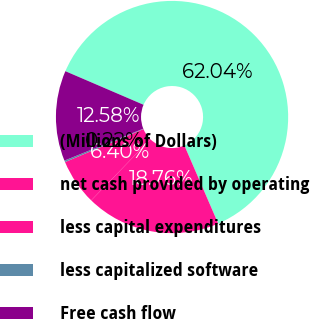Convert chart to OTSL. <chart><loc_0><loc_0><loc_500><loc_500><pie_chart><fcel>(Millions of Dollars)<fcel>net cash provided by operating<fcel>less capital expenditures<fcel>less capitalized software<fcel>Free cash flow<nl><fcel>62.04%<fcel>18.76%<fcel>6.4%<fcel>0.22%<fcel>12.58%<nl></chart> 